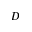<formula> <loc_0><loc_0><loc_500><loc_500>D</formula> 